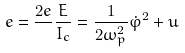Convert formula to latex. <formula><loc_0><loc_0><loc_500><loc_500>e = \frac { 2 e } { } \frac { E } { I _ { c } } = \frac { 1 } { 2 \omega _ { p } ^ { 2 } } \dot { \varphi } ^ { 2 } + u</formula> 